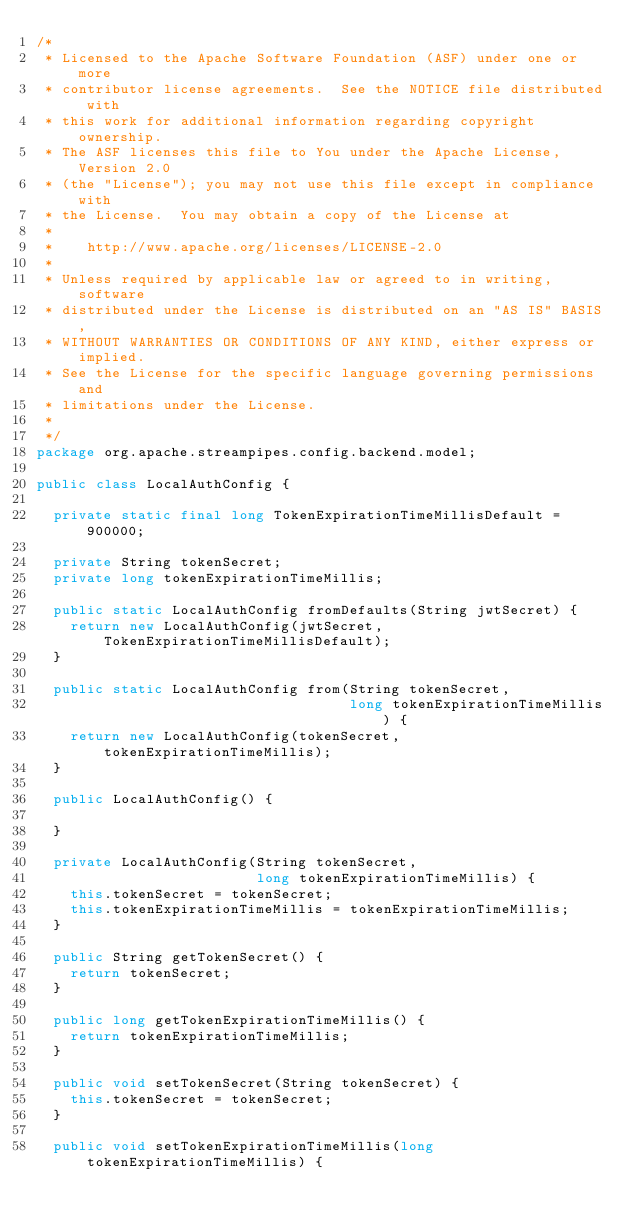Convert code to text. <code><loc_0><loc_0><loc_500><loc_500><_Java_>/*
 * Licensed to the Apache Software Foundation (ASF) under one or more
 * contributor license agreements.  See the NOTICE file distributed with
 * this work for additional information regarding copyright ownership.
 * The ASF licenses this file to You under the Apache License, Version 2.0
 * (the "License"); you may not use this file except in compliance with
 * the License.  You may obtain a copy of the License at
 *
 *    http://www.apache.org/licenses/LICENSE-2.0
 *
 * Unless required by applicable law or agreed to in writing, software
 * distributed under the License is distributed on an "AS IS" BASIS,
 * WITHOUT WARRANTIES OR CONDITIONS OF ANY KIND, either express or implied.
 * See the License for the specific language governing permissions and
 * limitations under the License.
 *
 */
package org.apache.streampipes.config.backend.model;

public class LocalAuthConfig {

  private static final long TokenExpirationTimeMillisDefault = 900000;

  private String tokenSecret;
  private long tokenExpirationTimeMillis;

  public static LocalAuthConfig fromDefaults(String jwtSecret) {
    return new LocalAuthConfig(jwtSecret, TokenExpirationTimeMillisDefault);
  }

  public static LocalAuthConfig from(String tokenSecret,
                                     long tokenExpirationTimeMillis) {
    return new LocalAuthConfig(tokenSecret, tokenExpirationTimeMillis);
  }

  public LocalAuthConfig() {

  }

  private LocalAuthConfig(String tokenSecret,
                          long tokenExpirationTimeMillis) {
    this.tokenSecret = tokenSecret;
    this.tokenExpirationTimeMillis = tokenExpirationTimeMillis;
  }

  public String getTokenSecret() {
    return tokenSecret;
  }

  public long getTokenExpirationTimeMillis() {
    return tokenExpirationTimeMillis;
  }

  public void setTokenSecret(String tokenSecret) {
    this.tokenSecret = tokenSecret;
  }

  public void setTokenExpirationTimeMillis(long tokenExpirationTimeMillis) {</code> 